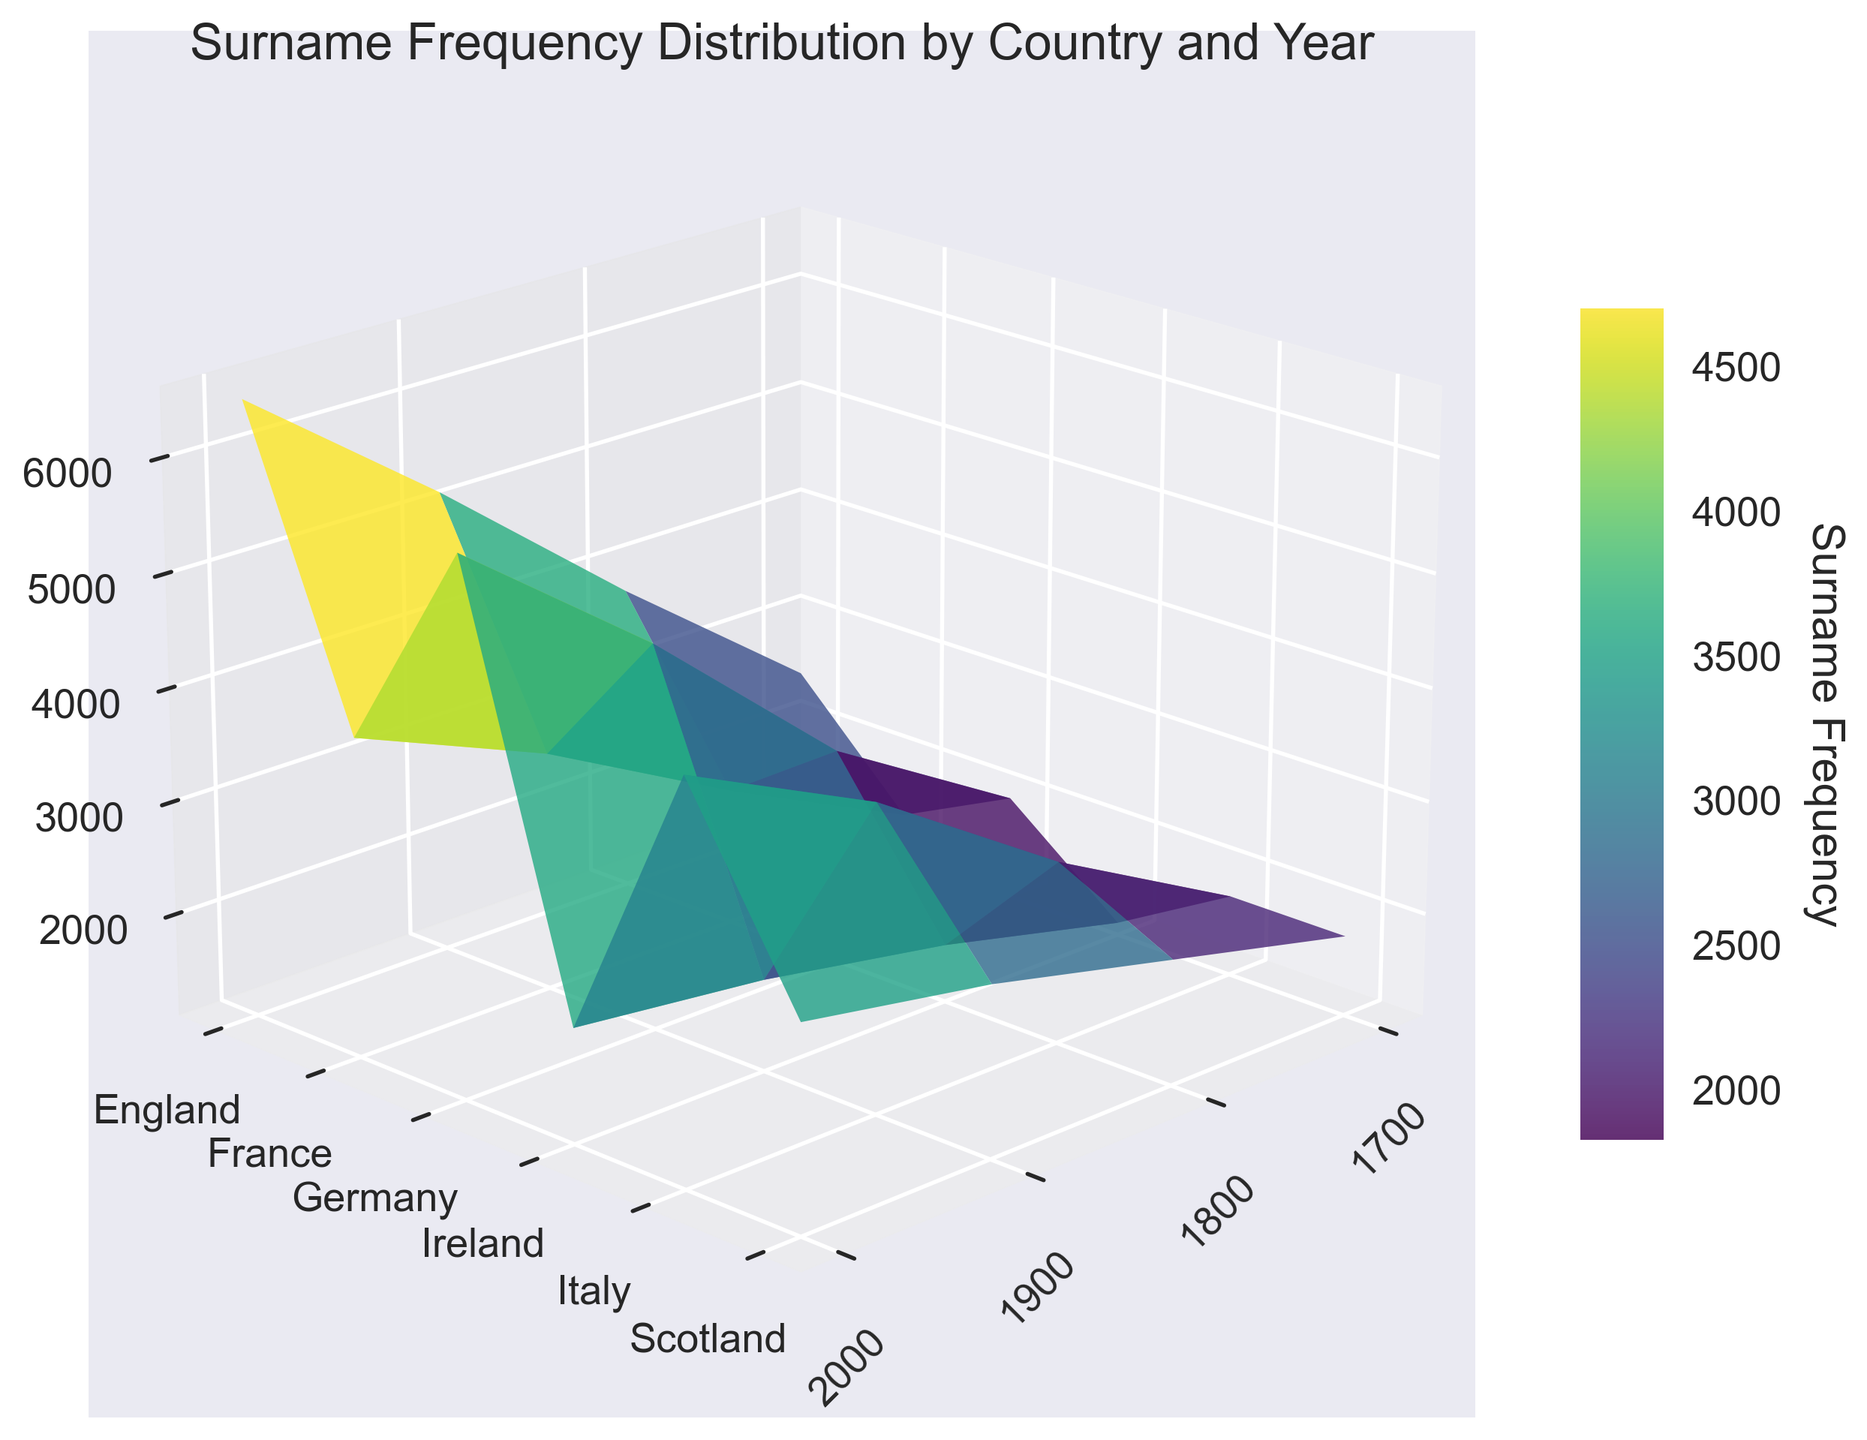What's the title of the figure? The title of the figure is located at the top and gives a summary of what the plot represents. In this plot, the title is "Surname Frequency Distribution by Country and Year".
Answer: Surname Frequency Distribution by Country and Year How is the frequency data represented on the plot? The frequency data is represented as a 3D surface where the z-axis shows the frequency of the surnames. The X and Y axes represent the years and countries, respectively. Changes in frequency values are illustrated through the height and color gradient of the surface.
Answer: 3D surface Which country had the highest surname frequency in the year 2000? By examining the frequency values on the z-axis for the year 2000, indicated on the x-axis, and comparing across different countries, we observe that England had the highest frequency.
Answer: England What is the trend for the surname frequency of 'MacDonald' in Scotland from 1700 to 2000? Reviewing the z-values (height) corresponding to Scotland across the timeline on the x-axis from 1700 to 2000, we note an increase in frequency from 1800 to 2900. This is a consistent upward trend.
Answer: Increasing trend Which country's surname frequency showed the least variation over the centuries? By comparing the surface variations (z-values) across different countries and centuries, we observe that Ireland's 'O'Brien' showed the least variation, with frequencies ranging only from 1200 to 2100.
Answer: Ireland What is the average frequency of 'Smith' in England across all available years? To determine the average, we sum the frequencies of 'Smith' in England for all years (2500 + 3800 + 5200 + 6500) and divide by the number of years (4). Calculation: (2500 + 3800 + 5200 + 6500) / 4 = 4500.
Answer: 4500 How does the surname frequency of 'Mueller' in Germany in 2000 compare with 'Rossi' in Italy in 1800? Cross-referencing the z-values in the plot for 'Mueller' in Germany in 2000 and 'Rossi' in Italy in 1800, we find that 'Mueller' has a higher frequency (5800) compared to 'Rossi' (2700).
Answer: Mueller is higher Which two countries had the same surname frequency in the year 1700, and what was that frequency? By viewing the z-values for the year 1700 on the x-axis and matching them across different countries, we find that both Scotland (MacDonald) and Italy (Rossi) had a frequency of 1800.
Answer: Scotland and Italy, 1800 What is the difference in surname frequency of 'Dubois' in France between years 1900 and 1800? To find the difference, subtract the frequencies of 'Dubois' in France in 1800 from the frequency in 1900. Calculation: 3200 - 2300 = 900.
Answer: 900 Does the surname 'O'Brien' in Ireland have a higher frequency in 2000 compared to 'Smith' in England in 1700? Comparing the z-values for 'O'Brien' in Ireland in 2000 (2100) and 'Smith' in England in 1700 (2500), we see that 'Smith' in England has a higher frequency.
Answer: No 